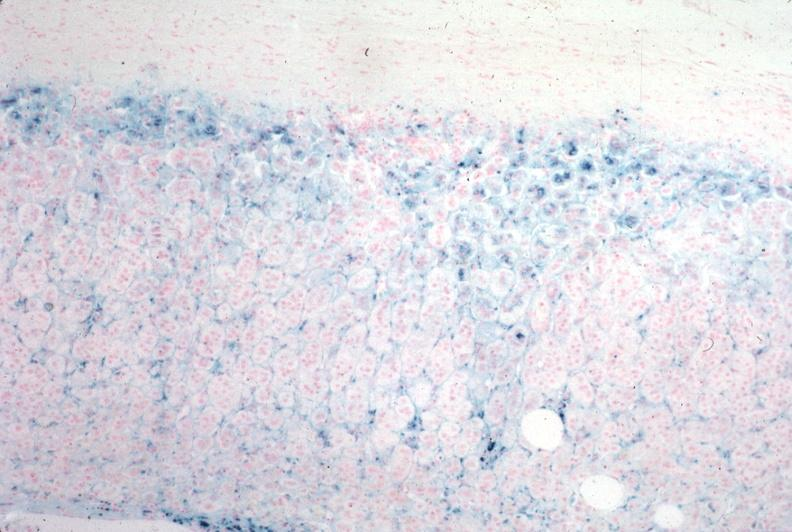s beckwith-wiedemann syndrome present?
Answer the question using a single word or phrase. No 